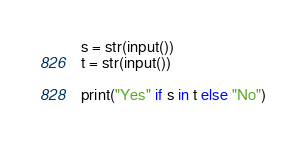<code> <loc_0><loc_0><loc_500><loc_500><_Python_>s = str(input())
t = str(input())

print("Yes" if s in t else "No")</code> 